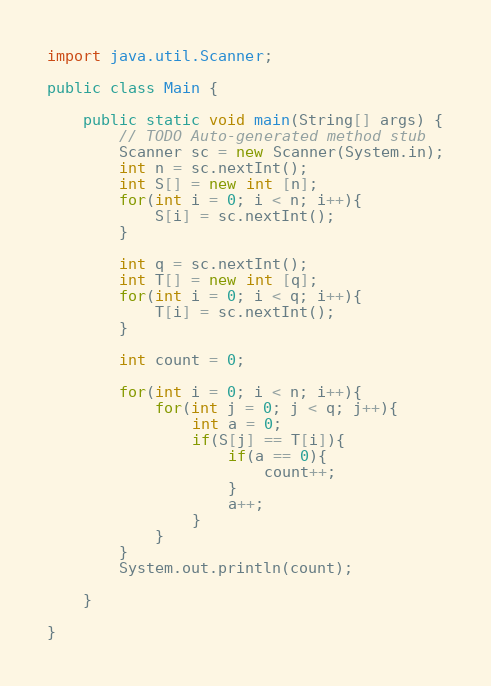Convert code to text. <code><loc_0><loc_0><loc_500><loc_500><_Java_>import java.util.Scanner;

public class Main {

	public static void main(String[] args) {
		// TODO Auto-generated method stub
		Scanner sc = new Scanner(System.in);
		int n = sc.nextInt();
		int S[] = new int [n];
		for(int i = 0; i < n; i++){
			S[i] = sc.nextInt();
		}
		
		int q = sc.nextInt();
		int T[] = new int [q];
		for(int i = 0; i < q; i++){
			T[i] = sc.nextInt();
		}
		
		int count = 0;
		
		for(int i = 0; i < n; i++){
			for(int j = 0; j < q; j++){
				int a = 0;
				if(S[j] == T[i]){
					if(a == 0){
						count++;
					}
					a++;
				}
			}
		}
		System.out.println(count);
		
	}

}</code> 